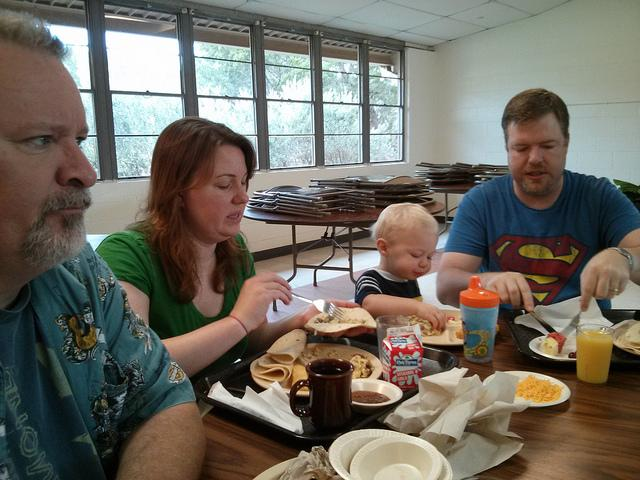What did the man with an S on his shirt likely read when he was young? Please explain your reasoning. comic books. The superman logo indicates he read comics. 